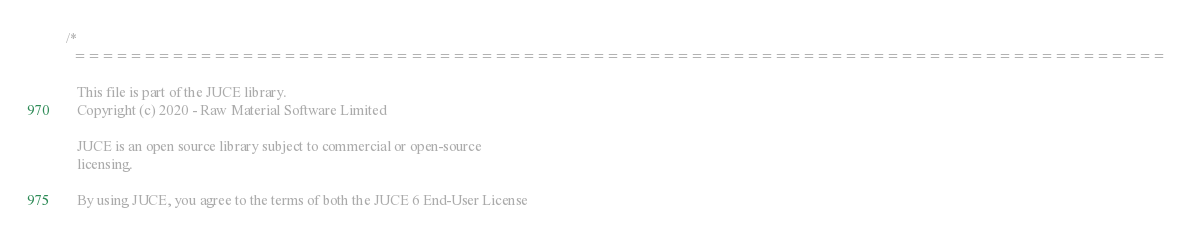<code> <loc_0><loc_0><loc_500><loc_500><_C++_>/*
  ==============================================================================

   This file is part of the JUCE library.
   Copyright (c) 2020 - Raw Material Software Limited

   JUCE is an open source library subject to commercial or open-source
   licensing.

   By using JUCE, you agree to the terms of both the JUCE 6 End-User License</code> 